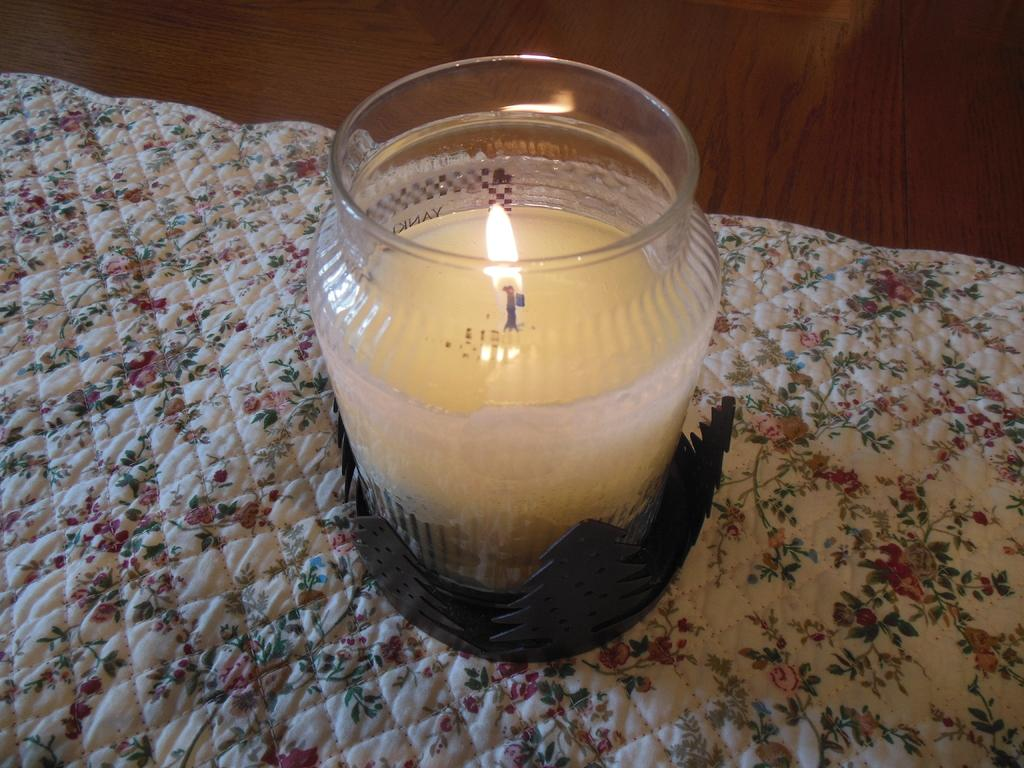What object is present in the image that can provide light? There is a candle in the image. How is the candle contained in the image? The candle is kept in a jar. What is the candle placed on in the image? The candle is placed on a cloth. What type of calculator is visible on the cloth next to the candle? There is no calculator present in the image; only a candle in a jar placed on a cloth is visible. 